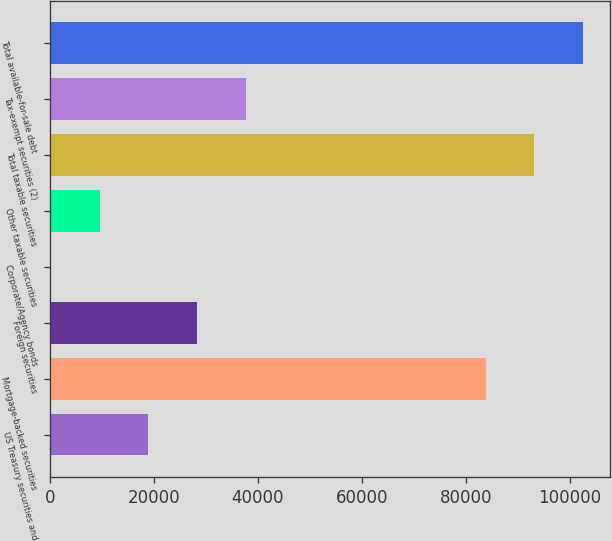<chart> <loc_0><loc_0><loc_500><loc_500><bar_chart><fcel>US Treasury securities and<fcel>Mortgage-backed securities<fcel>Foreign securities<fcel>Corporate/Agency bonds<fcel>Other taxable securities<fcel>Total taxable securities<fcel>Tax-exempt securities (2)<fcel>Total available-for-sale debt<nl><fcel>18951.4<fcel>83826<fcel>28334.6<fcel>185<fcel>9568.2<fcel>93209.2<fcel>37717.8<fcel>102592<nl></chart> 